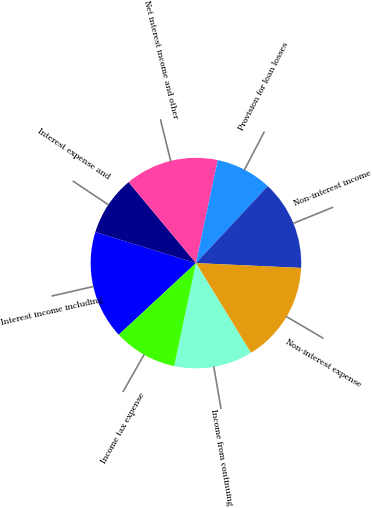<chart> <loc_0><loc_0><loc_500><loc_500><pie_chart><fcel>Interest income including<fcel>Interest expense and<fcel>Net interest income and other<fcel>Provision for loan losses<fcel>Non-interest income<fcel>Non-interest expense<fcel>Income from continuing<fcel>Income tax expense<nl><fcel>16.67%<fcel>9.2%<fcel>14.37%<fcel>8.62%<fcel>13.79%<fcel>15.52%<fcel>12.07%<fcel>9.77%<nl></chart> 